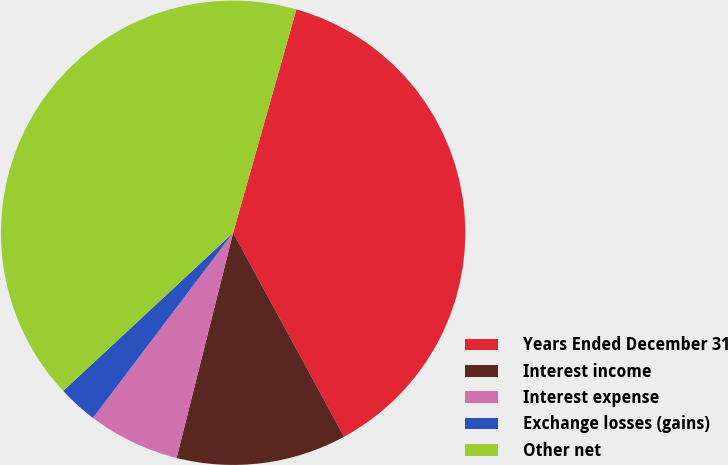<chart> <loc_0><loc_0><loc_500><loc_500><pie_chart><fcel>Years Ended December 31<fcel>Interest income<fcel>Interest expense<fcel>Exchange losses (gains)<fcel>Other net<nl><fcel>37.68%<fcel>11.84%<fcel>6.4%<fcel>2.76%<fcel>41.32%<nl></chart> 